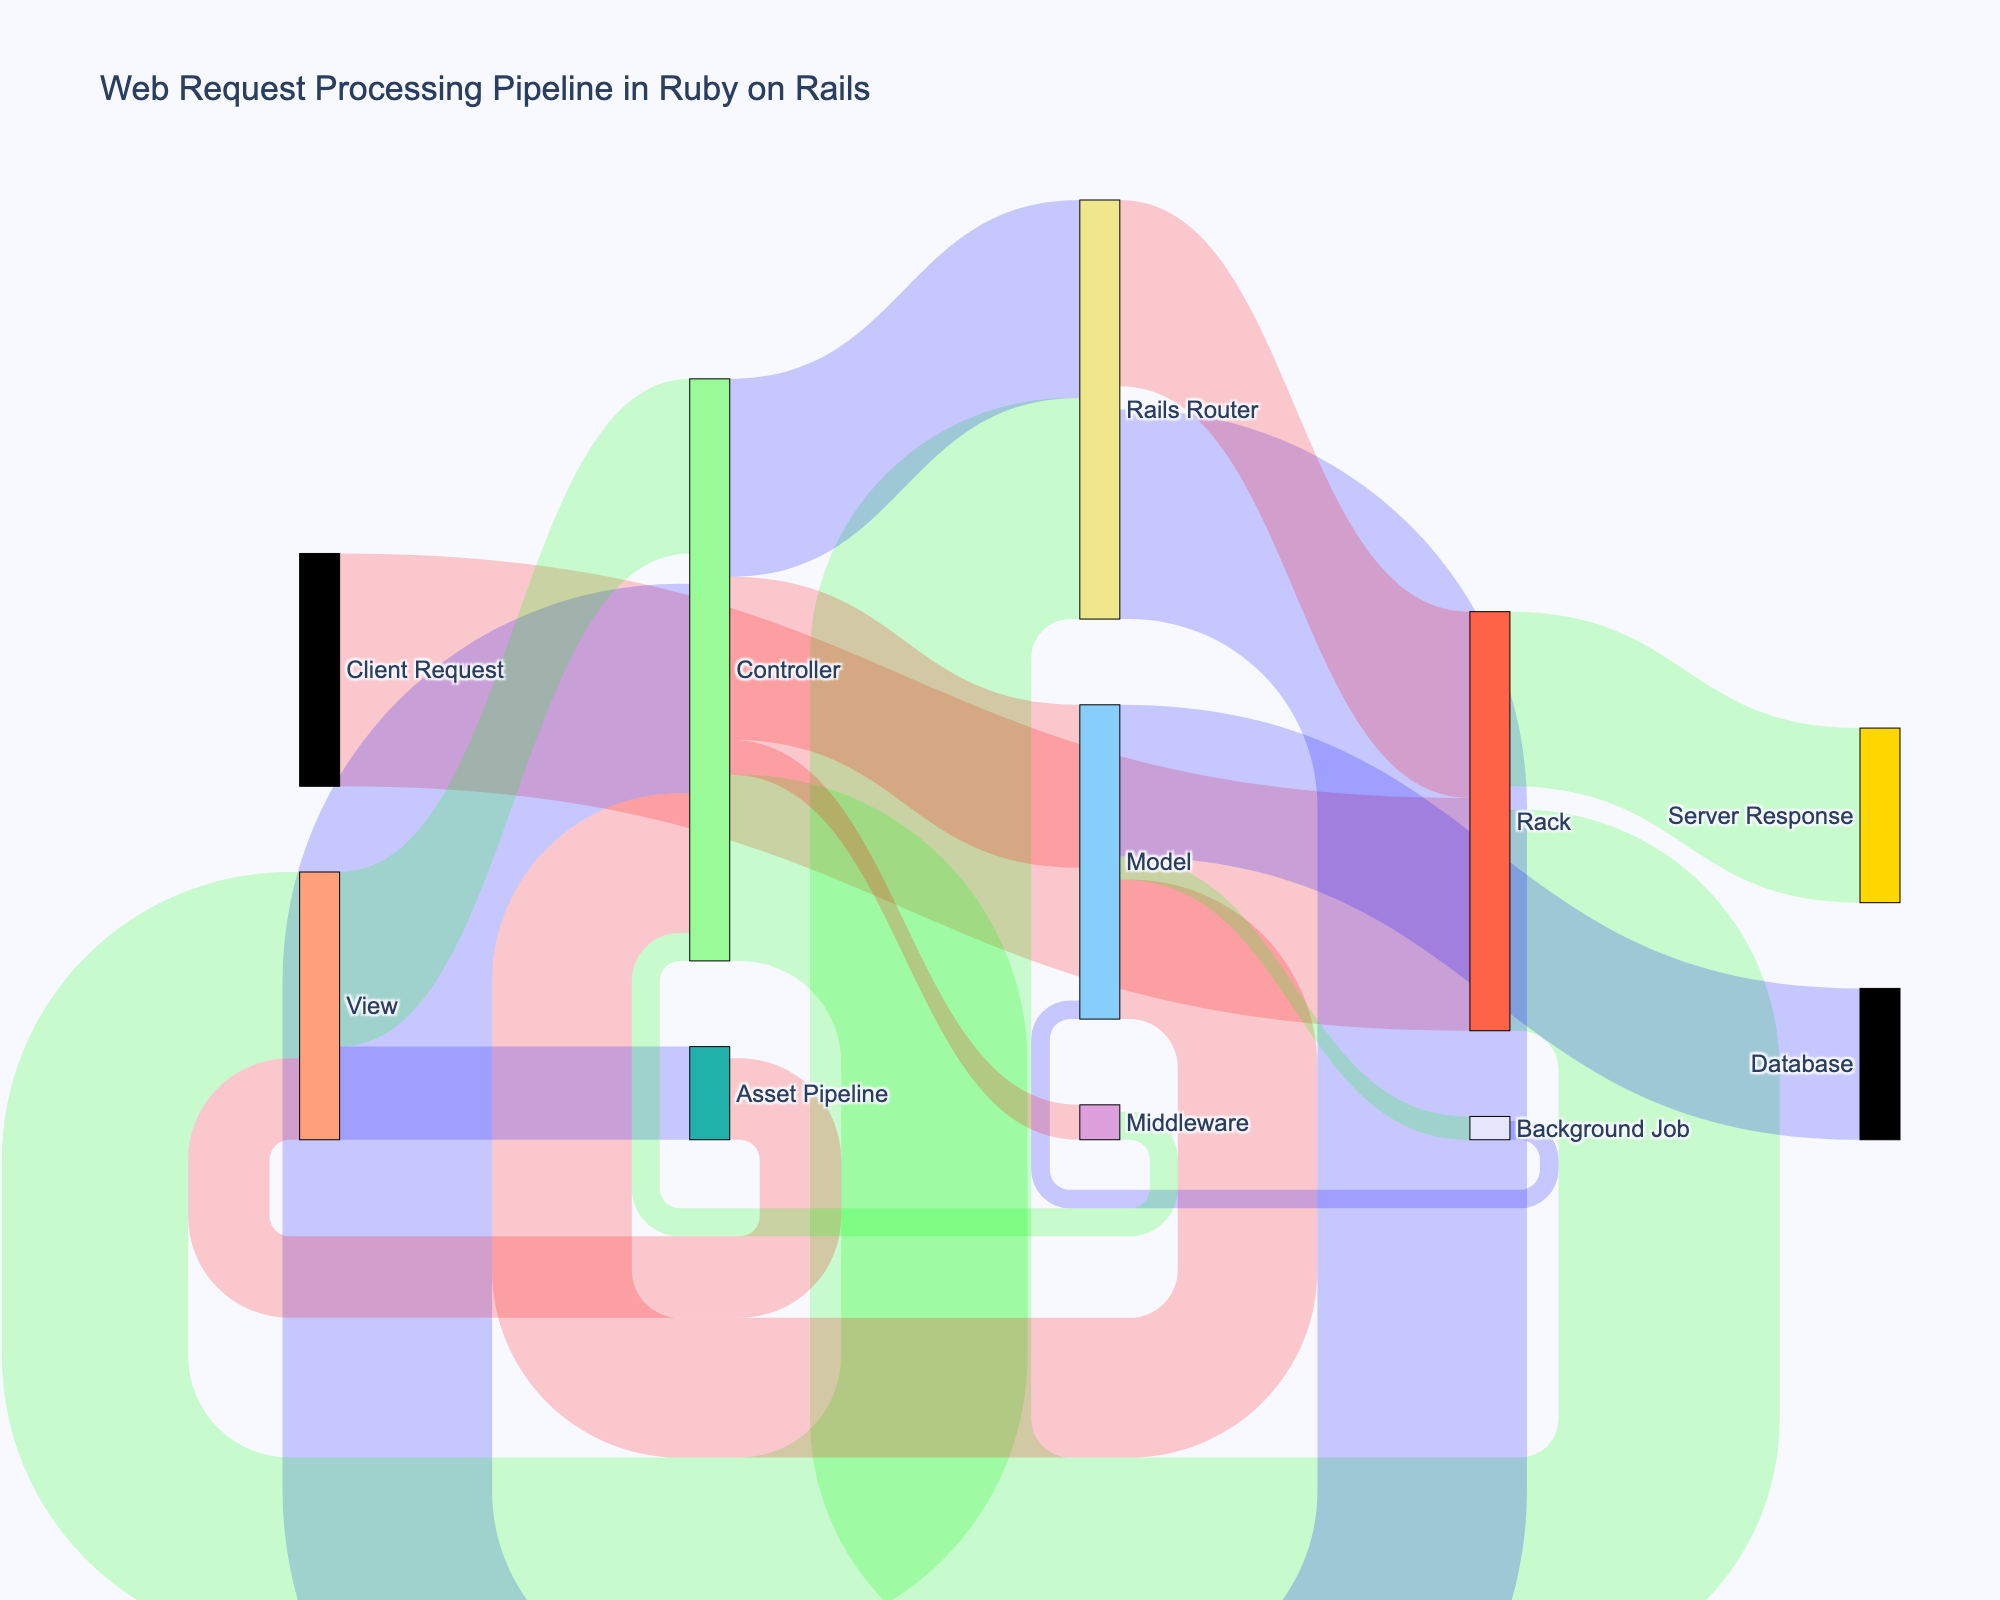What's the title of the diagram? The title is typically found at the top of the diagram and provides a summary of the visualization. In this case, it explains what the entire Sankey Diagram is about.
Answer: Web Request Processing Pipeline in Ruby on Rails How many nodes are present in the Sankey Diagram? Nodes are individual points or blocks in the diagram that represent different stages or components, and each unique label counts as one node.
Answer: 13 Which three components in the diagram directly receive values flowing from the Controller? By following the connections from the Controller node, we can see that it has links to three other components.
Answer: Model, View, Middleware What is the total value flowing out from the Controller? To find the total value, sum up all the values that flow out from the Controller node. This would include connections to Model, View, and Middleware.
Answer: 70 + 80 + 15 = 165 Which component receives the smallest value from any other node, and what is that value? Look for the link with the smallest value in the diagram and identify both the target component and the value.
Answer: Background Job, 10 What is the largest value flowing into the Controller? Identify the highest value among all the incoming connections to the Controller node, which are from Model, View, and Middleware.
Answer: View, 75 What is the combined value flowing into the Rails Router from all sources? Sum up all the values that flow into the Rails Router. This would include all connections leading to the Rails Router from other components.
Answer: 95 + 85 = 180 Which component has a direct connection to both the Rails Router and the Server Response? Find the node that has direct links (connections) to both the specified nodes: Rails Router and Server Response.
Answer: Rack How many components does the Model node interact with and what are their names? Count the distinct nodes that have either an incoming or outgoing connection with the Model node and list them.
Answer: 5: Controller, Database, Background Job, Middleware, View Is the value flowing from the Client Request to the Server Response greater than the combined value flowing from the Model to all its targets? First, determine the total value going from Client Request to Server Response, then sum up all the values flowing out from the Model to various targets, and compare these two amounts.
Answer: Yes: 100 > 65 + 60 + 10 = 135 